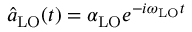<formula> <loc_0><loc_0><loc_500><loc_500>\hat { a } _ { L O } ( t ) = \alpha _ { L O } e ^ { - i \omega _ { L O } t }</formula> 